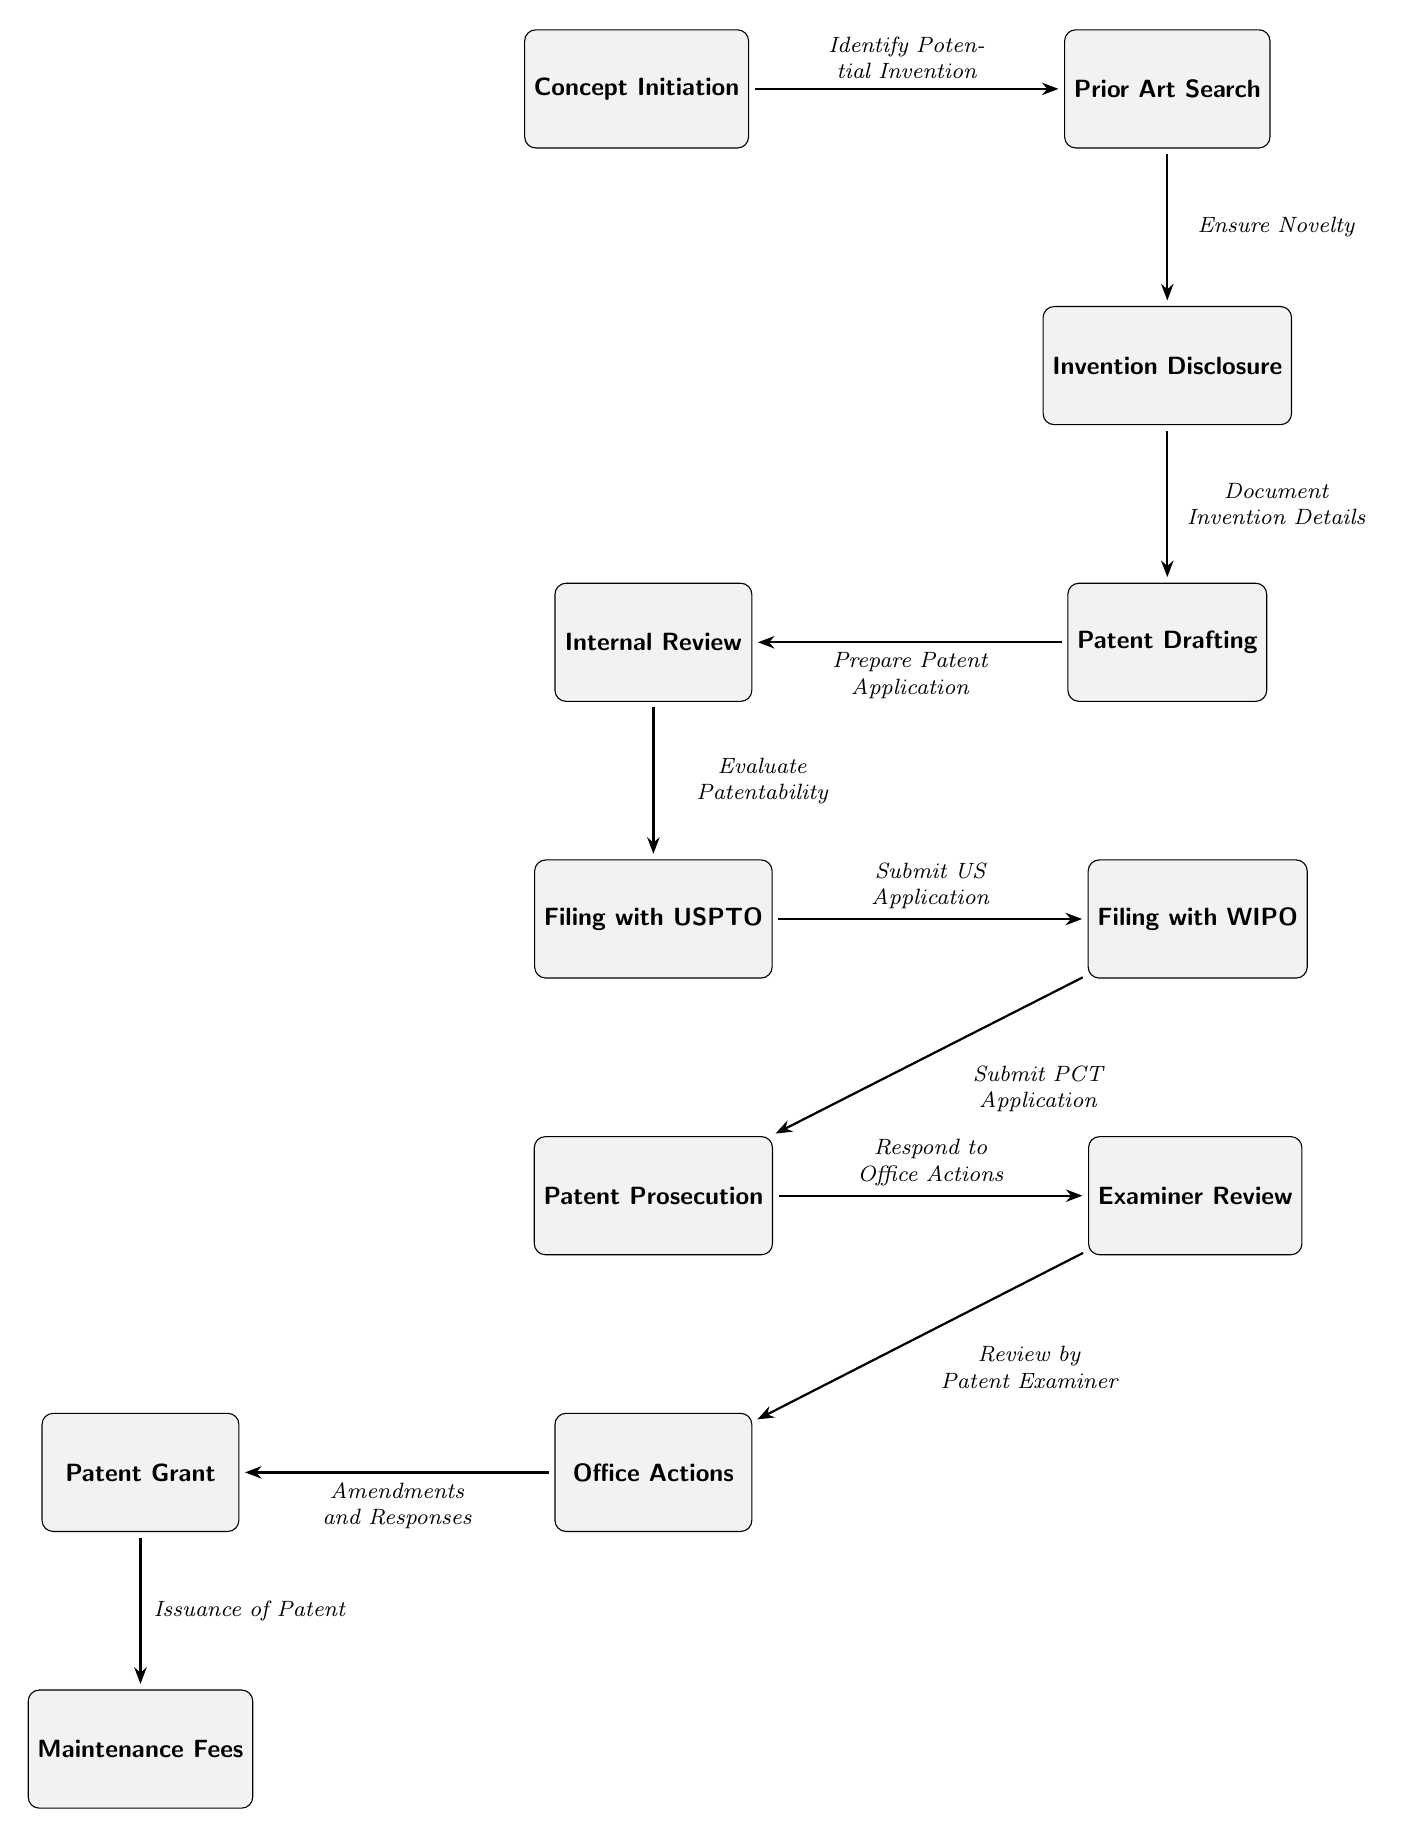What is the first step in the patent application workflow? The first step in the workflow is labeled as "Concept Initiation," which signifies the starting point of identifying a potential invention.
Answer: Concept Initiation How many nodes are present in the diagram? By counting the boxes representing different stages, there are a total of 12 distinct nodes in the diagram, each corresponding to a step in the patent application process.
Answer: 12 What does the node “Examiner Review” precede? The node "Examiner Review" is positioned directly before "Office Actions," indicating that the review by the patent examiner happens before any office actions are taken.
Answer: Office Actions What action is taken after "Patent Grant"? Following "Patent Grant," the next step is "Maintenance Fees," which indicates the ongoing obligations required to maintain the validity of the patent after it has been granted.
Answer: Maintenance Fees What is the relationship between “Filing with USPTO” and “Filing with WIPO”? "Filing with USPTO" is followed by "Filing with WIPO," indicating that a submission to the USPTO is done prior to the submission to the WIPO, showing a sequential relationship between the two filing processes.
Answer: Filing with WIPO What does "Office Actions" include? "Office Actions" consists of "Amendments and Responses," showing that the actions taken in response to the examiner's review involve amendments to the application.
Answer: Amendments and Responses Which step involves evaluating patentability? The step that involves evaluating patentability is "Internal Review," which happens before the filing with USPTO, indicating that an internal assessment is conducted before officially submitting the application.
Answer: Internal Review How does one transition from "Patent Drafting" to "Filing with USPTO"? The transition from "Patent Drafting" to "Filing with USPTO" happens through "Internal Review," meaning that after drafting the patent application, it must undergo an internal evaluation before it is filed officially.
Answer: Internal Review What step follows "Respond to Office Actions"? The step that follows "Respond to Office Actions" is "Patent Grant," where, assuming all actions have been appropriately addressed, the patent is issued after review and responses.
Answer: Patent Grant 